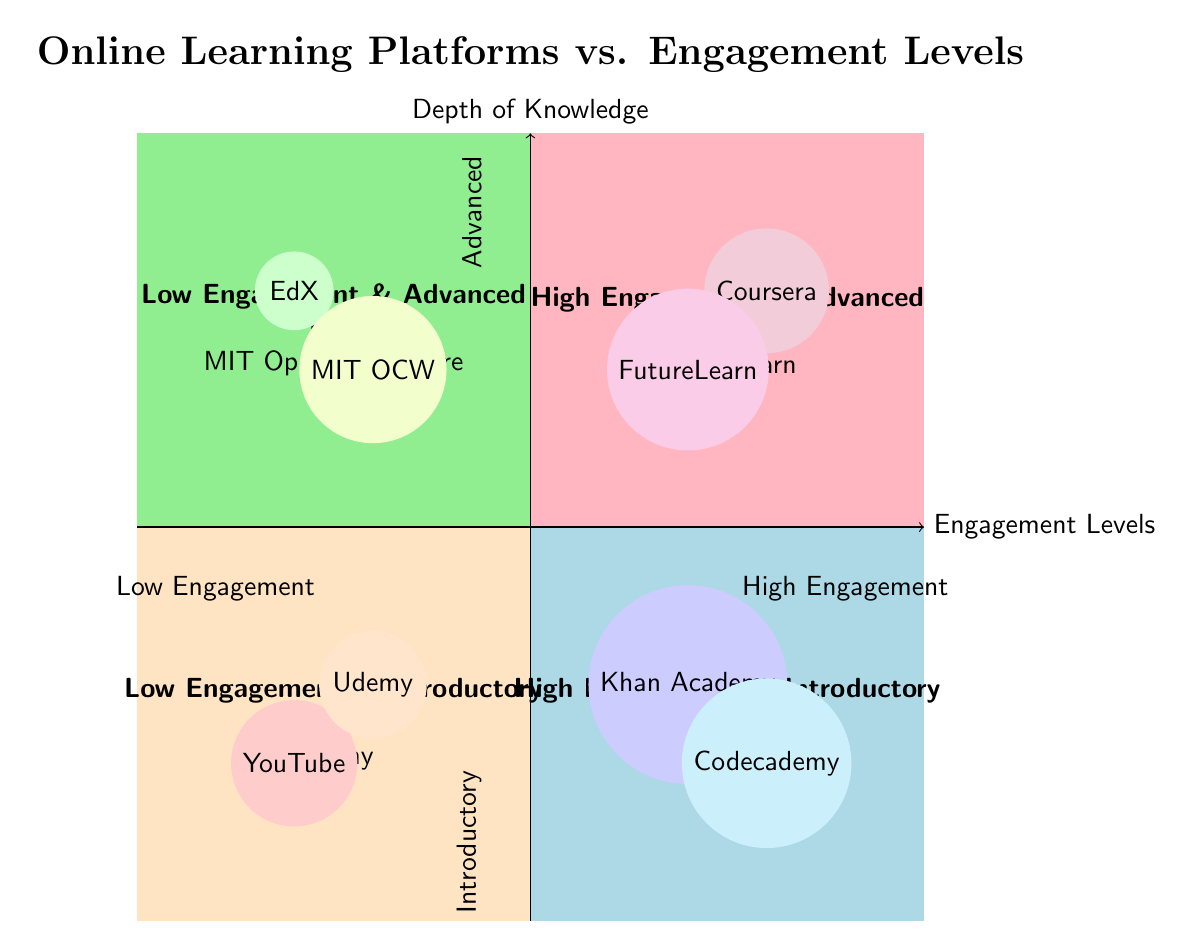What platforms are in the "Low Engagement & Introductory" quadrant? The "Low Engagement & Introductory" quadrant contains platforms that provide basic courses with minimal interaction. Upon examining the quadrant labeled for low engagement and introductory levels, the platforms listed there are YouTube and Udemy.
Answer: YouTube, Udemy Which platform is associated with "High Engagement & Advanced" learning? In the "High Engagement & Advanced" quadrant, platforms are dedicated to advanced learning that requires significant student commitment. The platforms shown in this quadrant are Coursera and FutureLearn. The answer focuses on the most prominent representative, which is Coursera.
Answer: Coursera How many platforms are in the "Low Engagement & Advanced" quadrant? To determine the number of platforms in the "Low Engagement & Advanced" quadrant, I look for the listed platforms, which are EdX and MIT OpenCourseWare. By counting these entries, I find there are two platforms.
Answer: 2 Which quadrant has the platform "Codecademy"? To find the quadrant with "Codecademy", I check the platforms listed in each quadrant. "Codecademy" is listed in the "High Engagement & Introductory" quadrant, which focuses on hands-on introductory courses that require engagement.
Answer: High Engagement & Introductory Which quadrant has platforms suitable for self-paced learning? Self-paced learning typically fits under low engagement levels where interactivity is less critical. In examining the quadrants, both the "Low Engagement & Advanced" and "Low Engagement & Introductory" quadrants have platforms that allow for self-paced learning. More specifically, EdX and MIT OpenCourseWare are found in the "Low Engagement & Advanced" quadrant, making it the correct answer when focusing on advanced study methods.
Answer: Low Engagement & Advanced What is the common depth of knowledge for platforms in the "High Engagement & Introductory" quadrant? The "High Engagement & Introductory" quadrant is characterized by courses that provide foundational knowledge while requiring significant interaction and engagement. The platforms listed, such as Khan Academy and Codecademy, indicate the depth of knowledge is introductory here. Thus, the depth of knowledge is foundational or basic.
Answer: Introductory Which platforms have a description emphasizing peer interaction and projects? To find platforms that emphasize peer interaction and projects, I look at the descriptions in the quadrants, particularly the one indicating "High Engagement & Advanced". The platforms listed are Coursera and FutureLearn, both of which focus on peer assessments and active participation in projects.
Answer: Coursera, FutureLearn How does engagement level affect the types of courses offered on platforms? The quadrants show a clear relationship where higher engagement typically accompanies courses that delve deeper into the subject matter, depicted as advanced courses. For example, "Coursera" and "FutureLearn" in the "High Engagement & Advanced" quadrant offer advanced learning experiences, while platforms like "YouTube" offer introductory content in the "Low Engagement & Introductory" quadrant. Thus, higher engagement correlates with deeper and more committed learning environments.
Answer: Higher Engagement = Advanced Courses 